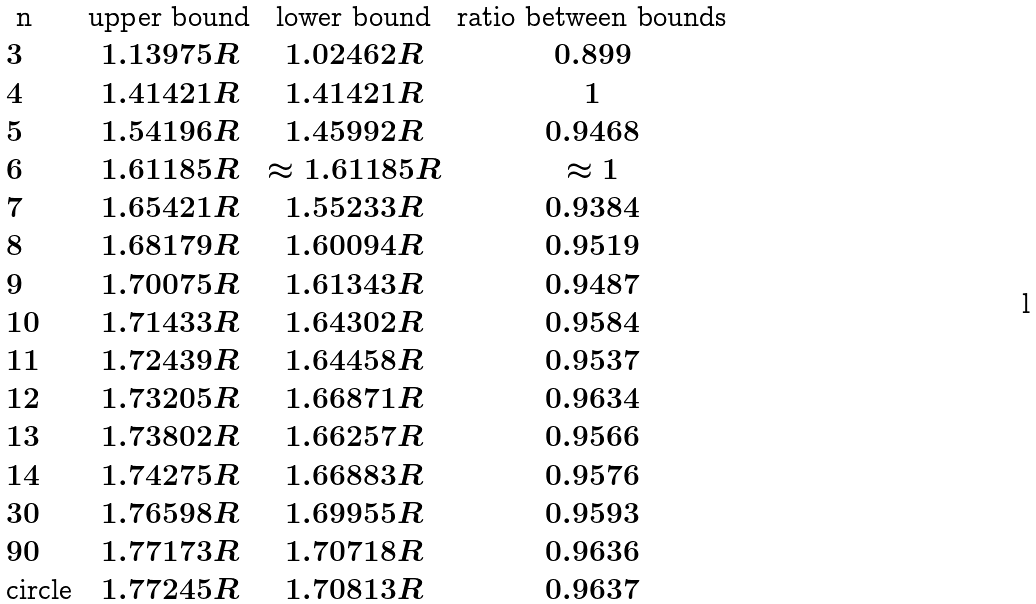Convert formula to latex. <formula><loc_0><loc_0><loc_500><loc_500>\begin{array} { l c c c } $ n $ & \text {upper bound} & \text {lower bound} & \text {ratio between bounds} \\ 3 & 1 . 1 3 9 7 5 R & 1 . 0 2 4 6 2 R & 0 . 8 9 9 \\ 4 & 1 . 4 1 4 2 1 R & 1 . 4 1 4 2 1 R & 1 \\ 5 & 1 . 5 4 1 9 6 R & 1 . 4 5 9 9 2 R & 0 . 9 4 6 8 \\ 6 & 1 . 6 1 1 8 5 R & \approx 1 . 6 1 1 8 5 R & \approx 1 \\ 7 & 1 . 6 5 4 2 1 R & 1 . 5 5 2 3 3 R & 0 . 9 3 8 4 \\ 8 & 1 . 6 8 1 7 9 R & 1 . 6 0 0 9 4 R & 0 . 9 5 1 9 \\ 9 & 1 . 7 0 0 7 5 R & 1 . 6 1 3 4 3 R & 0 . 9 4 8 7 \\ 1 0 & 1 . 7 1 4 3 3 R & 1 . 6 4 3 0 2 R & 0 . 9 5 8 4 \\ 1 1 & 1 . 7 2 4 3 9 R & 1 . 6 4 4 5 8 R & 0 . 9 5 3 7 \\ 1 2 & 1 . 7 3 2 0 5 R & 1 . 6 6 8 7 1 R & 0 . 9 6 3 4 \\ 1 3 & 1 . 7 3 8 0 2 R & 1 . 6 6 2 5 7 R & 0 . 9 5 6 6 \\ 1 4 & 1 . 7 4 2 7 5 R & 1 . 6 6 8 8 3 R & 0 . 9 5 7 6 \\ 3 0 & 1 . 7 6 5 9 8 R & 1 . 6 9 9 5 5 R & 0 . 9 5 9 3 \\ 9 0 & 1 . 7 7 1 7 3 R & 1 . 7 0 7 1 8 R & 0 . 9 6 3 6 \\ \text {circle} & 1 . 7 7 2 4 5 R & 1 . 7 0 8 1 3 R & 0 . 9 6 3 7 \\ \end{array}</formula> 